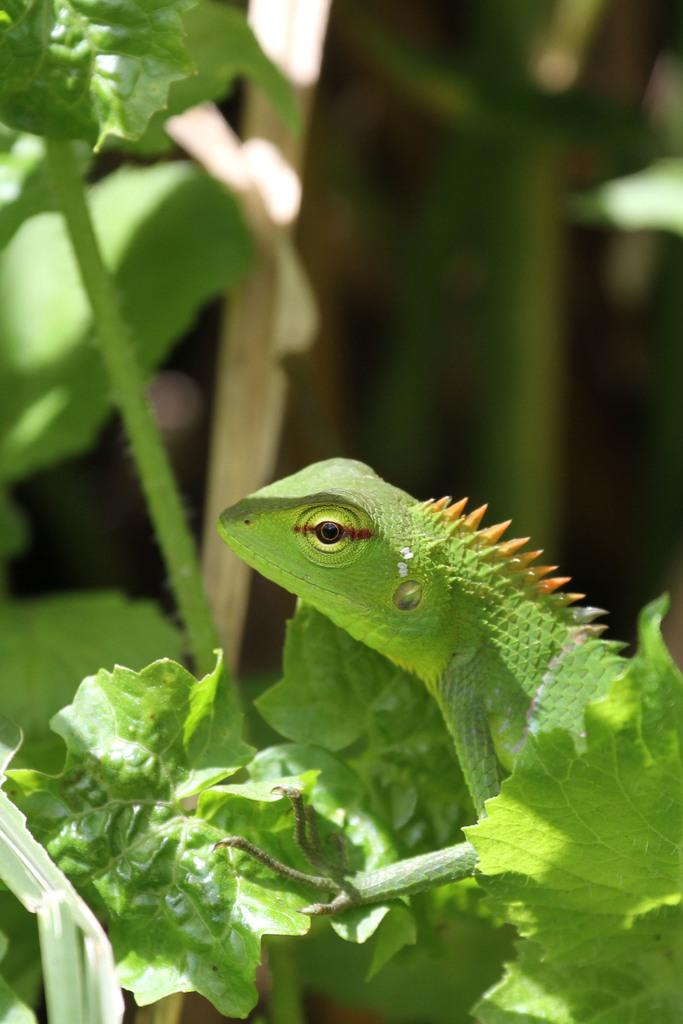What type of animal is in the image? There is a reptile in the image. What else can be seen in the image besides the reptile? There are plants in the image. What type of bread is being toasted in the image? There is no bread or toasting activity present in the image. 